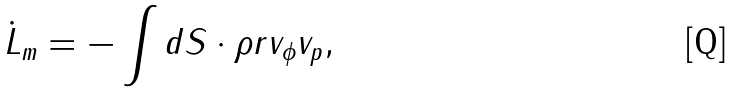<formula> <loc_0><loc_0><loc_500><loc_500>\dot { L } _ { m } = - \int d { S } \cdot \rho { r } v _ { \phi } { v } _ { p } ,</formula> 